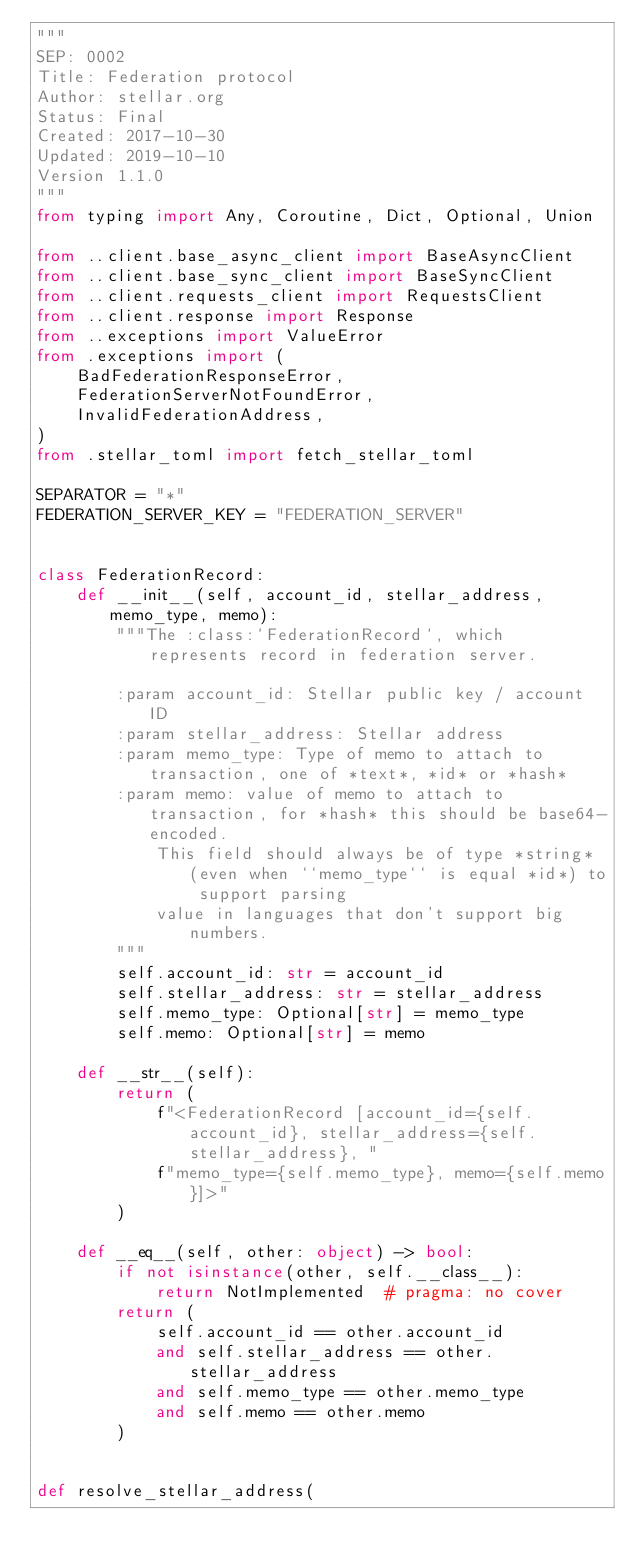<code> <loc_0><loc_0><loc_500><loc_500><_Python_>"""
SEP: 0002
Title: Federation protocol
Author: stellar.org
Status: Final
Created: 2017-10-30
Updated: 2019-10-10
Version 1.1.0
"""
from typing import Any, Coroutine, Dict, Optional, Union

from ..client.base_async_client import BaseAsyncClient
from ..client.base_sync_client import BaseSyncClient
from ..client.requests_client import RequestsClient
from ..client.response import Response
from ..exceptions import ValueError
from .exceptions import (
    BadFederationResponseError,
    FederationServerNotFoundError,
    InvalidFederationAddress,
)
from .stellar_toml import fetch_stellar_toml

SEPARATOR = "*"
FEDERATION_SERVER_KEY = "FEDERATION_SERVER"


class FederationRecord:
    def __init__(self, account_id, stellar_address, memo_type, memo):
        """The :class:`FederationRecord`, which represents record in federation server.

        :param account_id: Stellar public key / account ID
        :param stellar_address: Stellar address
        :param memo_type: Type of memo to attach to transaction, one of *text*, *id* or *hash*
        :param memo: value of memo to attach to transaction, for *hash* this should be base64-encoded.
            This field should always be of type *string* (even when ``memo_type`` is equal *id*) to support parsing
            value in languages that don't support big numbers.
        """
        self.account_id: str = account_id
        self.stellar_address: str = stellar_address
        self.memo_type: Optional[str] = memo_type
        self.memo: Optional[str] = memo

    def __str__(self):
        return (
            f"<FederationRecord [account_id={self.account_id}, stellar_address={self.stellar_address}, "
            f"memo_type={self.memo_type}, memo={self.memo}]>"
        )

    def __eq__(self, other: object) -> bool:
        if not isinstance(other, self.__class__):
            return NotImplemented  # pragma: no cover
        return (
            self.account_id == other.account_id
            and self.stellar_address == other.stellar_address
            and self.memo_type == other.memo_type
            and self.memo == other.memo
        )


def resolve_stellar_address(</code> 